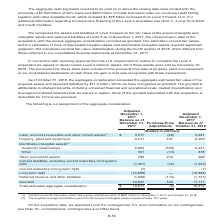According to Centurylink's financial document, What do cash, accounts receivable and other current assets include? accounts receivable, which had a gross contractual value of $884 million on November 1, 2017 and October 31, 2018. The document states: "(1) Includes accounts receivable, which had a gross contractual value of $884 million on November 1, 2017 and October 31, 2018. (2) The weighted-avera..." Also, What is the weighted-average amortization period for the identifiable intangible assets? According to the financial document, 12.0 years. The relevant text states: "r the acquired intangible assets is approximately 12.0 years...." Also, What is goodwill attributable to? The document contains multiple relevant values: strategic benefits, enhanced financial and operational scale, market diversification, leveraged combined networks. From the document: "cluding enhanced financial and operational scale, market diversification and leveraged combined networks that we expect to realize. None of the goodwi..." Additionally, Which period has a larger total estimated aggregate consideration? According to the financial document, December 31, 2017. The relevant text states: "ected in our consolidated financial statements at December 31, 2017...." Also, can you calculate: What is property, plant and equipment expressed as a ratio of the total estimated aggregate consideration under the balance as of December 31, 2017? Based on the calculation: 9,311/19,617, the result is 47.46 (percentage). This is based on the information: "3,317 (26) 3,291 Property, plant and equipment . 9,311 157 9,468 Identifiable intangible assets (2) . Customer relationships . 8,964 (533) 8,431 Other . 3 Total estimated aggregate consideration . $ 1..." The key data points involved are: 19,617, 9,311. Also, can you calculate: What is the percentage change in other non currrent assets in 2018? To answer this question, I need to perform calculations using the financial data. The calculation is: (998-782)/782, which equals 27.62 (percentage). This is based on the information: ". 391 (13) 378 Other noncurrent assets . 782 216 998 Current liabilities, excluding current maturities of long-term debt . (1,461) (32) (1,493) Current 31 Other . 391 (13) 378 Other noncurrent assets ..." The key data points involved are: 782, 998. 